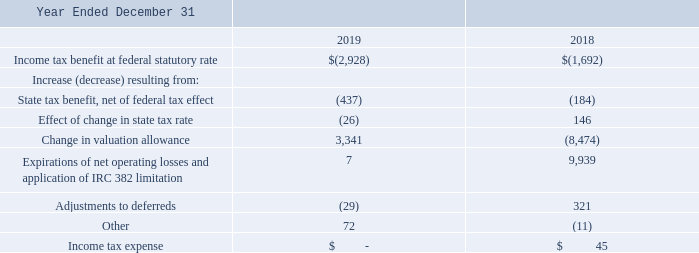Reconciliations between the amounts computed by applying the U.S. federal statutory tax rate to loss before income taxes, and income tax expense (benefit) follows (in thousands):
We determined no material liabilities related to uncertain income tax positions existed as of December 31, 2019 or 2018, based on our analysis of tax positions taken on income tax returns filed. Although we believe the amounts reflected in our tax returns substantially comply with applicable U.S. federal, state, and foreign tax regulations, the respective taxing authorities may take contrary positions based on their interpretation of the law. A tax position successfully challenged by a taxing authority could result in an adjustment to our provision or benefit for income taxes in the period in which a final determination is made.
What are the respective income tax benefits in 2018 and 2019?
Answer scale should be: thousand. 1,692, 2,928. What are the respective state tax benefit, net of federal tax effect in 2018 and 2019?
Answer scale should be: thousand. 184, 437. What are the respective expirations of net operating losses and application of IRC 382 limitation in 2018 and 2019?
Answer scale should be: thousand. 9,939, 7. What is the average income tax benefit in 2018 and 2019?
Answer scale should be: thousand. (1,692 + 2,928)/2 
Answer: 2310. What is the change in income tax benefit between 2018 and 2019?
Answer scale should be: thousand. 2,928 - 1,692 
Answer: 1236. What is the percentage change in the income tax benefit between 2018 and 2019?
Answer scale should be: percent. (2,928 - 1,692)/1,692 
Answer: 73.05. 